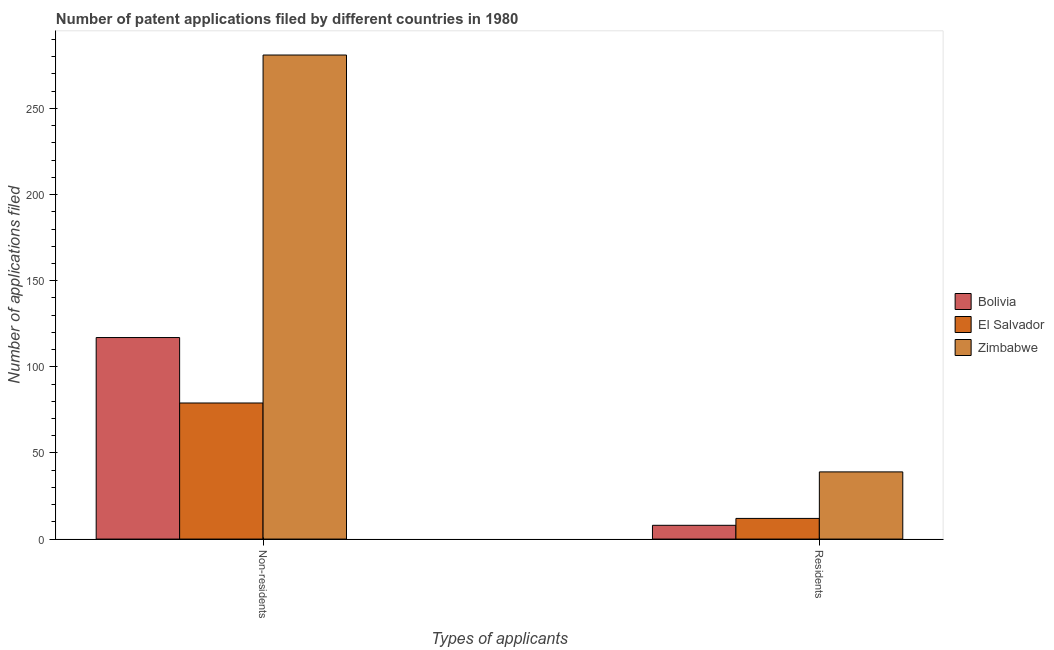How many different coloured bars are there?
Your answer should be compact. 3. Are the number of bars per tick equal to the number of legend labels?
Provide a succinct answer. Yes. Are the number of bars on each tick of the X-axis equal?
Provide a succinct answer. Yes. How many bars are there on the 2nd tick from the left?
Provide a short and direct response. 3. What is the label of the 1st group of bars from the left?
Your answer should be compact. Non-residents. What is the number of patent applications by non residents in Zimbabwe?
Your answer should be very brief. 281. Across all countries, what is the maximum number of patent applications by residents?
Give a very brief answer. 39. Across all countries, what is the minimum number of patent applications by non residents?
Ensure brevity in your answer.  79. In which country was the number of patent applications by non residents maximum?
Provide a short and direct response. Zimbabwe. In which country was the number of patent applications by non residents minimum?
Keep it short and to the point. El Salvador. What is the total number of patent applications by residents in the graph?
Provide a short and direct response. 59. What is the difference between the number of patent applications by non residents in Bolivia and that in El Salvador?
Your response must be concise. 38. What is the difference between the number of patent applications by residents in Bolivia and the number of patent applications by non residents in El Salvador?
Keep it short and to the point. -71. What is the average number of patent applications by non residents per country?
Offer a very short reply. 159. What is the difference between the number of patent applications by residents and number of patent applications by non residents in Zimbabwe?
Ensure brevity in your answer.  -242. In how many countries, is the number of patent applications by residents greater than 190 ?
Offer a terse response. 0. What is the ratio of the number of patent applications by non residents in Zimbabwe to that in Bolivia?
Your answer should be compact. 2.4. Is the number of patent applications by non residents in El Salvador less than that in Bolivia?
Make the answer very short. Yes. What does the 3rd bar from the left in Non-residents represents?
Make the answer very short. Zimbabwe. What does the 3rd bar from the right in Residents represents?
Your response must be concise. Bolivia. Are all the bars in the graph horizontal?
Your answer should be compact. No. How many countries are there in the graph?
Make the answer very short. 3. What is the difference between two consecutive major ticks on the Y-axis?
Make the answer very short. 50. Does the graph contain any zero values?
Provide a short and direct response. No. Where does the legend appear in the graph?
Your response must be concise. Center right. What is the title of the graph?
Your answer should be compact. Number of patent applications filed by different countries in 1980. Does "Papua New Guinea" appear as one of the legend labels in the graph?
Provide a short and direct response. No. What is the label or title of the X-axis?
Keep it short and to the point. Types of applicants. What is the label or title of the Y-axis?
Your response must be concise. Number of applications filed. What is the Number of applications filed of Bolivia in Non-residents?
Offer a very short reply. 117. What is the Number of applications filed in El Salvador in Non-residents?
Your answer should be compact. 79. What is the Number of applications filed in Zimbabwe in Non-residents?
Your answer should be very brief. 281. What is the Number of applications filed in Bolivia in Residents?
Provide a short and direct response. 8. What is the Number of applications filed in El Salvador in Residents?
Provide a succinct answer. 12. Across all Types of applicants, what is the maximum Number of applications filed of Bolivia?
Make the answer very short. 117. Across all Types of applicants, what is the maximum Number of applications filed in El Salvador?
Give a very brief answer. 79. Across all Types of applicants, what is the maximum Number of applications filed in Zimbabwe?
Your answer should be very brief. 281. Across all Types of applicants, what is the minimum Number of applications filed of Bolivia?
Provide a short and direct response. 8. Across all Types of applicants, what is the minimum Number of applications filed of Zimbabwe?
Ensure brevity in your answer.  39. What is the total Number of applications filed in Bolivia in the graph?
Offer a very short reply. 125. What is the total Number of applications filed of El Salvador in the graph?
Provide a succinct answer. 91. What is the total Number of applications filed of Zimbabwe in the graph?
Ensure brevity in your answer.  320. What is the difference between the Number of applications filed of Bolivia in Non-residents and that in Residents?
Make the answer very short. 109. What is the difference between the Number of applications filed of Zimbabwe in Non-residents and that in Residents?
Give a very brief answer. 242. What is the difference between the Number of applications filed in Bolivia in Non-residents and the Number of applications filed in El Salvador in Residents?
Keep it short and to the point. 105. What is the difference between the Number of applications filed in Bolivia in Non-residents and the Number of applications filed in Zimbabwe in Residents?
Offer a very short reply. 78. What is the average Number of applications filed in Bolivia per Types of applicants?
Make the answer very short. 62.5. What is the average Number of applications filed of El Salvador per Types of applicants?
Your answer should be very brief. 45.5. What is the average Number of applications filed in Zimbabwe per Types of applicants?
Your answer should be compact. 160. What is the difference between the Number of applications filed in Bolivia and Number of applications filed in El Salvador in Non-residents?
Your response must be concise. 38. What is the difference between the Number of applications filed of Bolivia and Number of applications filed of Zimbabwe in Non-residents?
Offer a very short reply. -164. What is the difference between the Number of applications filed of El Salvador and Number of applications filed of Zimbabwe in Non-residents?
Make the answer very short. -202. What is the difference between the Number of applications filed in Bolivia and Number of applications filed in Zimbabwe in Residents?
Make the answer very short. -31. What is the difference between the Number of applications filed in El Salvador and Number of applications filed in Zimbabwe in Residents?
Your answer should be compact. -27. What is the ratio of the Number of applications filed in Bolivia in Non-residents to that in Residents?
Keep it short and to the point. 14.62. What is the ratio of the Number of applications filed in El Salvador in Non-residents to that in Residents?
Keep it short and to the point. 6.58. What is the ratio of the Number of applications filed in Zimbabwe in Non-residents to that in Residents?
Your answer should be compact. 7.21. What is the difference between the highest and the second highest Number of applications filed of Bolivia?
Your answer should be very brief. 109. What is the difference between the highest and the second highest Number of applications filed in El Salvador?
Make the answer very short. 67. What is the difference between the highest and the second highest Number of applications filed of Zimbabwe?
Your answer should be very brief. 242. What is the difference between the highest and the lowest Number of applications filed in Bolivia?
Your response must be concise. 109. What is the difference between the highest and the lowest Number of applications filed in El Salvador?
Provide a short and direct response. 67. What is the difference between the highest and the lowest Number of applications filed of Zimbabwe?
Offer a terse response. 242. 